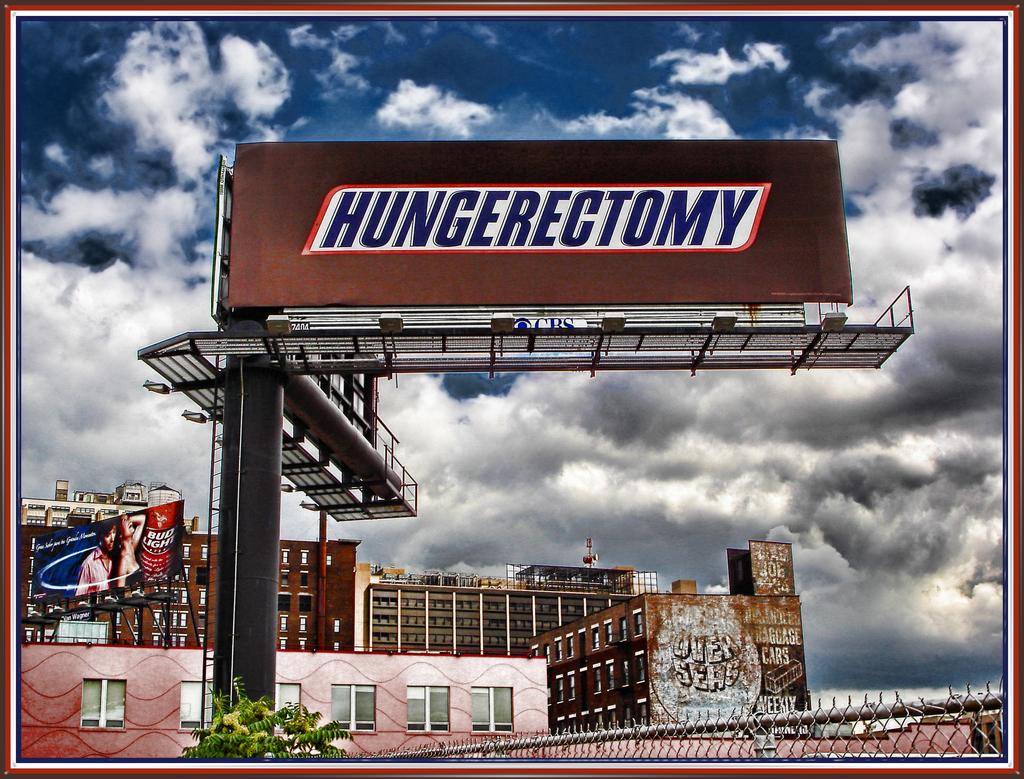What does the sign say?
Keep it short and to the point. Hungerectomy. 